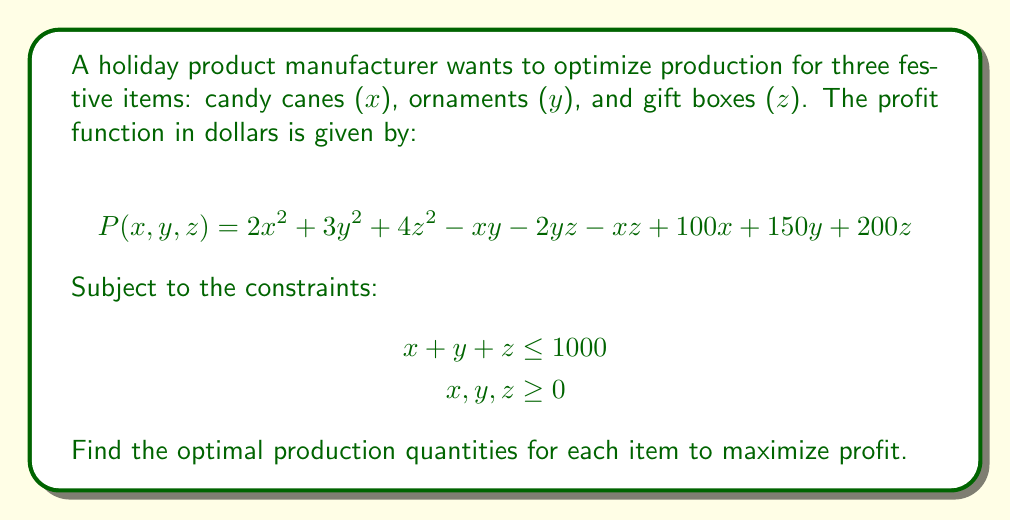Can you solve this math problem? To find the optimal production quantities, we need to maximize the profit function subject to the given constraints. We'll use the method of Lagrange multipliers:

1) Form the Lagrangian function:
   $$L(x,y,z,\lambda) = 2x^2 + 3y^2 + 4z^2 - xy - 2yz - xz + 100x + 150y + 200z + \lambda(1000 - x - y - z)$$

2) Take partial derivatives and set them equal to zero:
   $$\frac{\partial L}{\partial x} = 4x - y - z + 100 - \lambda = 0$$
   $$\frac{\partial L}{\partial y} = 6y - x - 2z + 150 - \lambda = 0$$
   $$\frac{\partial L}{\partial z} = 8z - x - 2y + 200 - \lambda = 0$$
   $$\frac{\partial L}{\partial \lambda} = 1000 - x - y - z = 0$$

3) Solve the system of equations:
   From the last equation: $z = 1000 - x - y$
   Substituting this into the first three equations:
   $$4x - y - (1000 - x - y) + 100 - \lambda = 0$$
   $$6y - x - 2(1000 - x - y) + 150 - \lambda = 0$$
   $$8(1000 - x - y) - x - 2y + 200 - \lambda = 0$$

4) Simplify:
   $$5x + 0y - 900 - \lambda = 0$$
   $$x + 8y - 1850 - \lambda = 0$$
   $$-9x - 10y + 8200 - \lambda = 0$$

5) Solve these equations:
   Subtracting the first from the second: $8y - x = 950$
   Subtracting the first from the third: $-14x - 10y = 9100$
   
   Solving these simultaneously:
   $x \approx 285.7$, $y \approx 153.6$, $z \approx 560.7$

6) Rounding to the nearest whole number (as we can't produce fractional items):
   $x = 286$, $y = 154$, $z = 560$
Answer: 286 candy canes, 154 ornaments, 560 gift boxes 